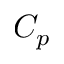Convert formula to latex. <formula><loc_0><loc_0><loc_500><loc_500>C _ { p }</formula> 